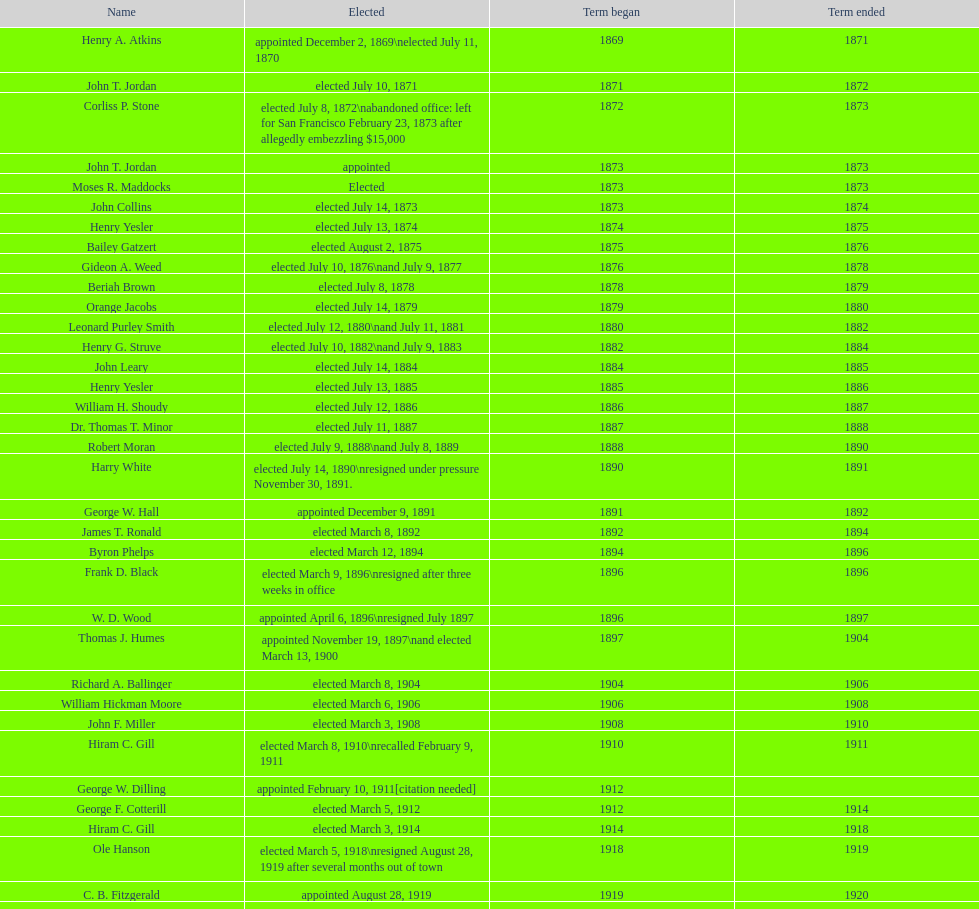Which individual held the position of seattle, washington's mayor prior to their appointment to the department of transportation under the nixon administration? James d'Orma Braman. 